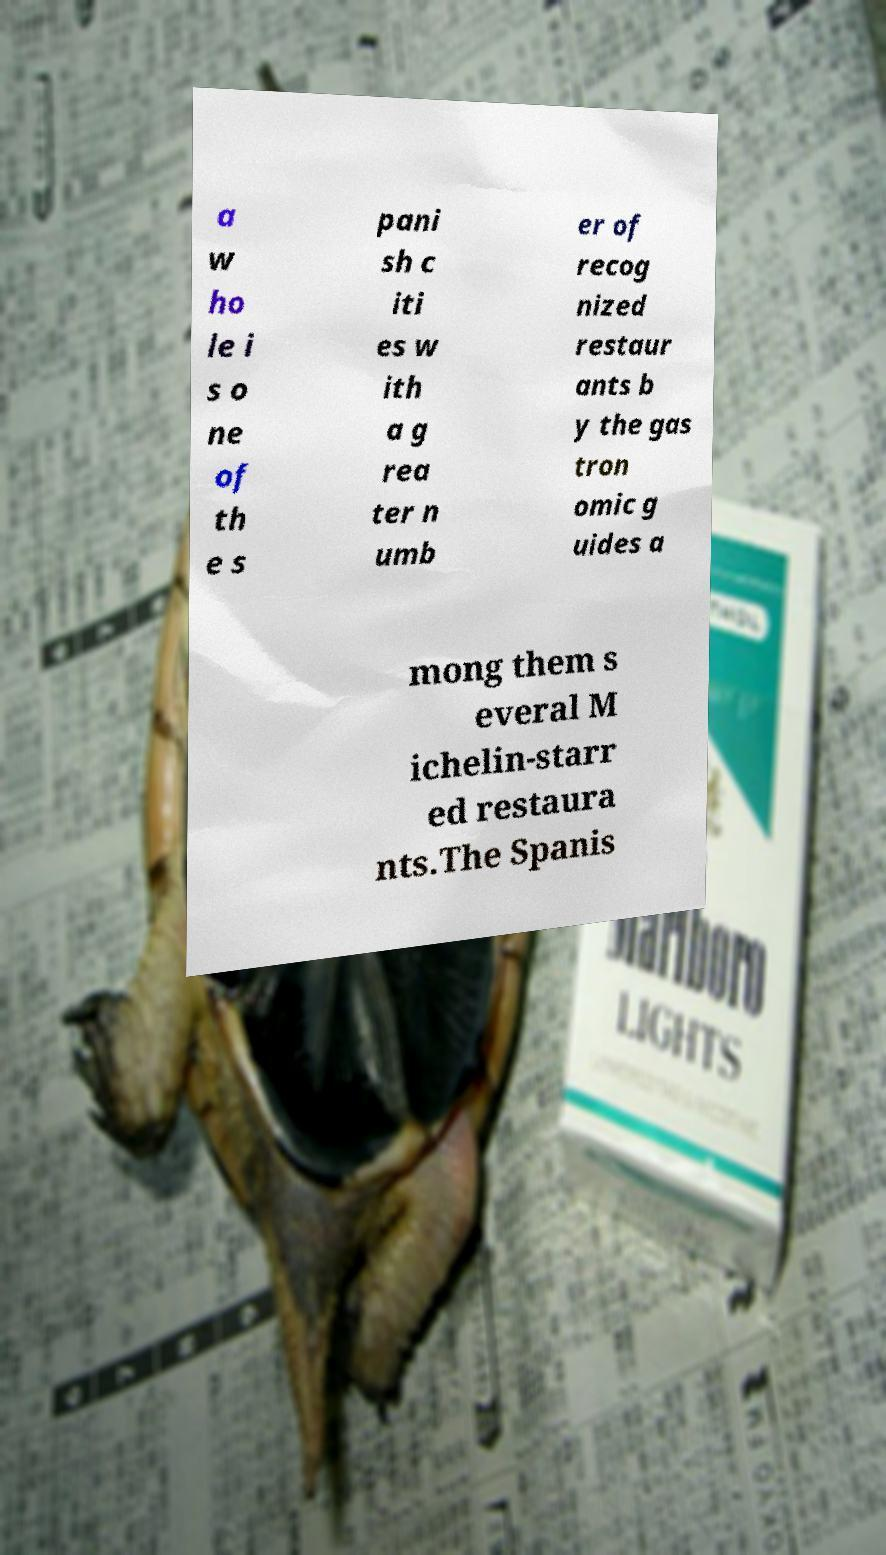Can you accurately transcribe the text from the provided image for me? a w ho le i s o ne of th e s pani sh c iti es w ith a g rea ter n umb er of recog nized restaur ants b y the gas tron omic g uides a mong them s everal M ichelin-starr ed restaura nts.The Spanis 